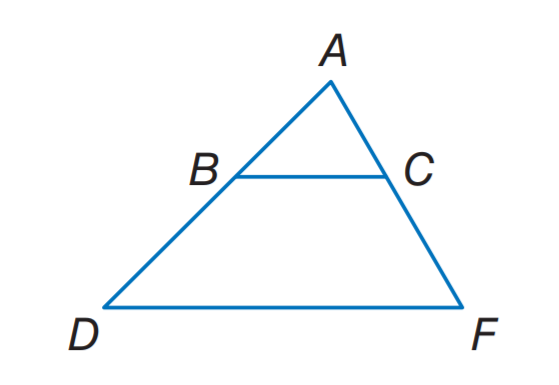How can we confirm if triangles ABD and ACF are indeed similar? Triangular similarity can be confirmed by establishing the equality of corresponding angles or proving that the ratio of the lengths of corresponding sides are equal. Since BC is parallel to DF and they form a pair of alternate interior angles with line segment AD, which is transversal, the alternate interior angles are equal. This establishes the angle-angle criterion for similarity between triangles ABD and ACF. Therefore, since two angles are enough to confirm similarity, we have our proof. We could also measure or calculate the angle values if needed, as similarity implies the two triangles have equal corresponding angles. 